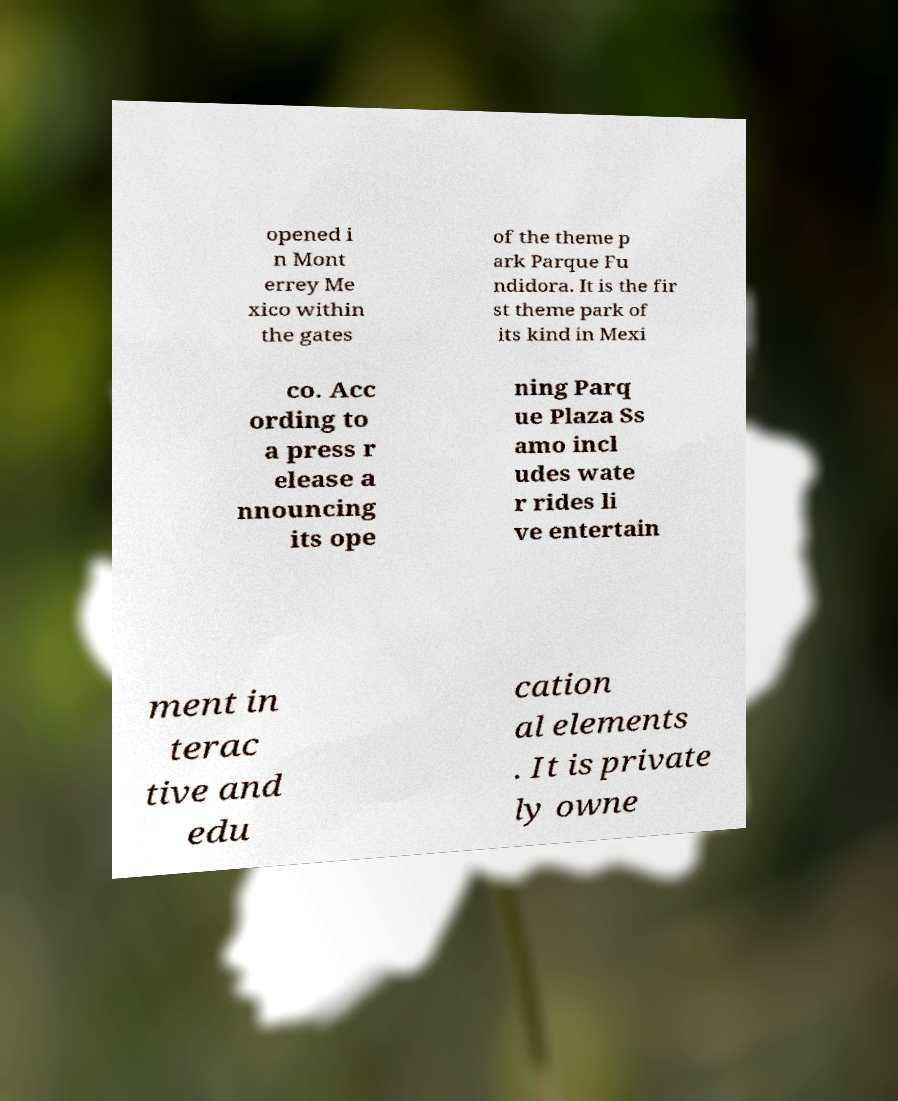Can you read and provide the text displayed in the image?This photo seems to have some interesting text. Can you extract and type it out for me? opened i n Mont errey Me xico within the gates of the theme p ark Parque Fu ndidora. It is the fir st theme park of its kind in Mexi co. Acc ording to a press r elease a nnouncing its ope ning Parq ue Plaza Ss amo incl udes wate r rides li ve entertain ment in terac tive and edu cation al elements . It is private ly owne 